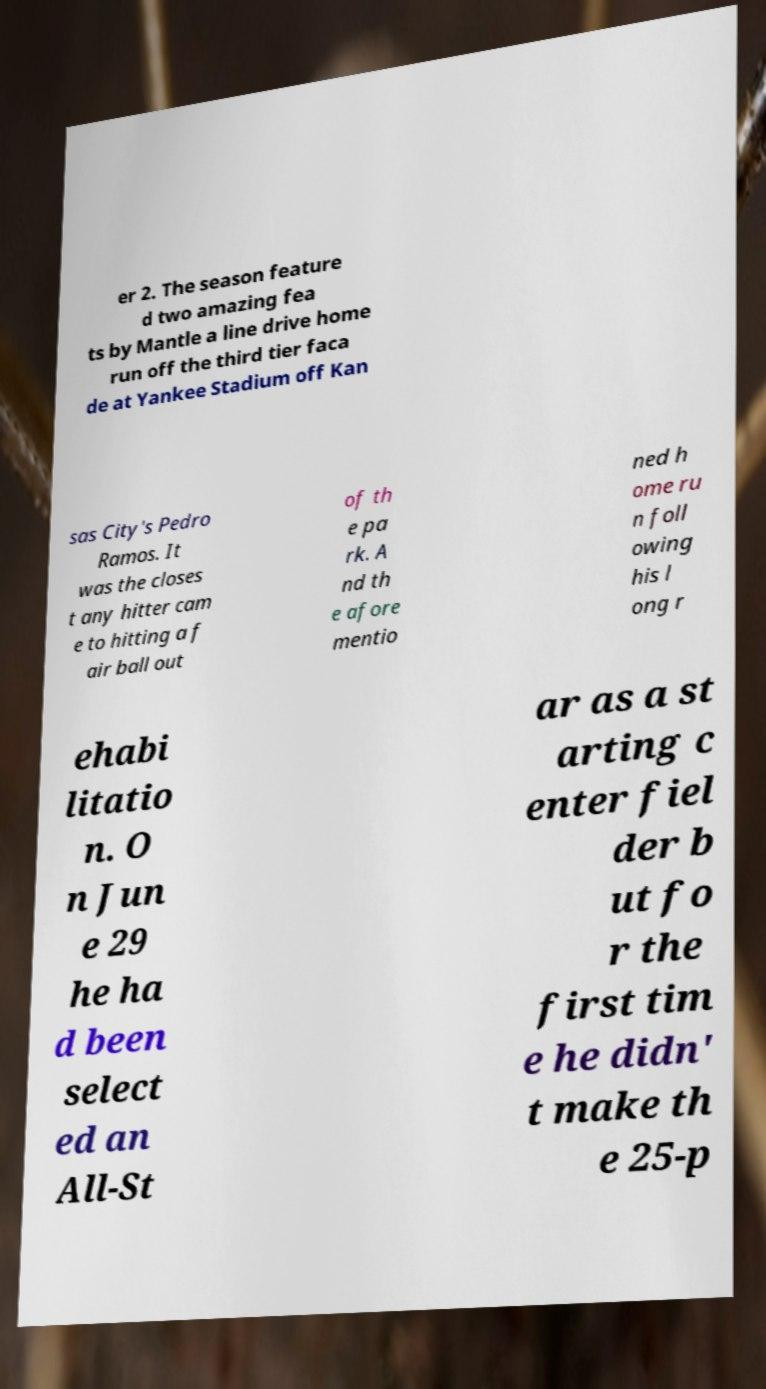Can you accurately transcribe the text from the provided image for me? er 2. The season feature d two amazing fea ts by Mantle a line drive home run off the third tier faca de at Yankee Stadium off Kan sas City's Pedro Ramos. It was the closes t any hitter cam e to hitting a f air ball out of th e pa rk. A nd th e afore mentio ned h ome ru n foll owing his l ong r ehabi litatio n. O n Jun e 29 he ha d been select ed an All-St ar as a st arting c enter fiel der b ut fo r the first tim e he didn' t make th e 25-p 